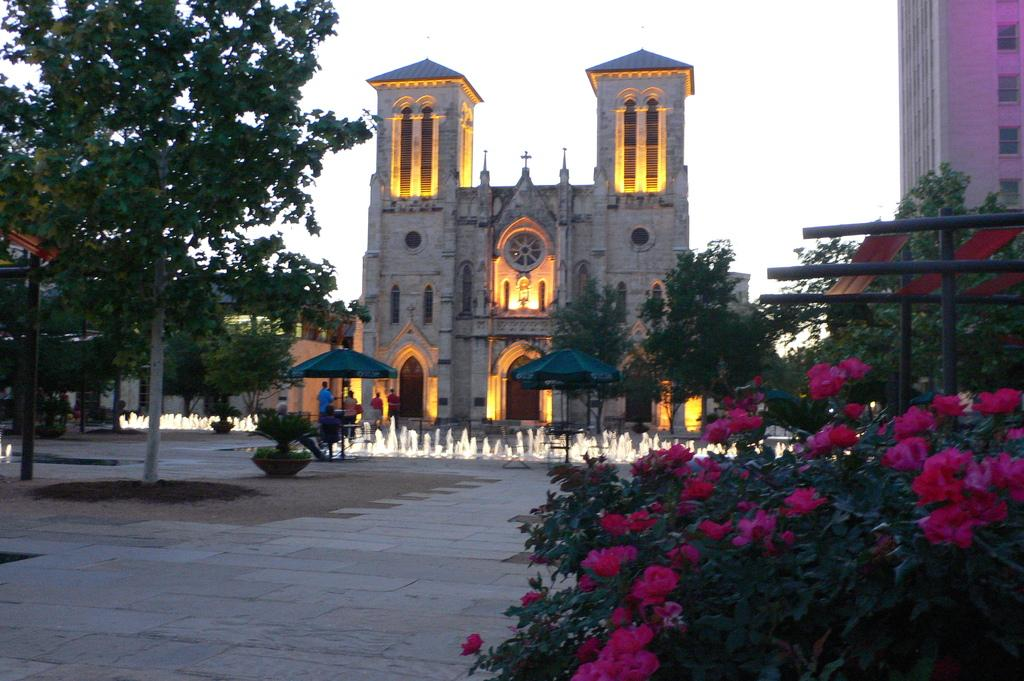What structures are located in the center of the image? There are buildings in the center of the image. What objects can be seen at the bottom of the image? There are parasols at the bottom of the image. What feature is present in the image that provides water? There is a fountain in the image. What type of vegetation is visible in the image? There are trees in the image. What is visible at the top of the image? The sky is visible at the top of the image. Can you tell me how much powder the grandfather is holding in the image? There is no grandfather or powder present in the image. What type of development is taking place in the image? The image does not depict any development or construction process. 